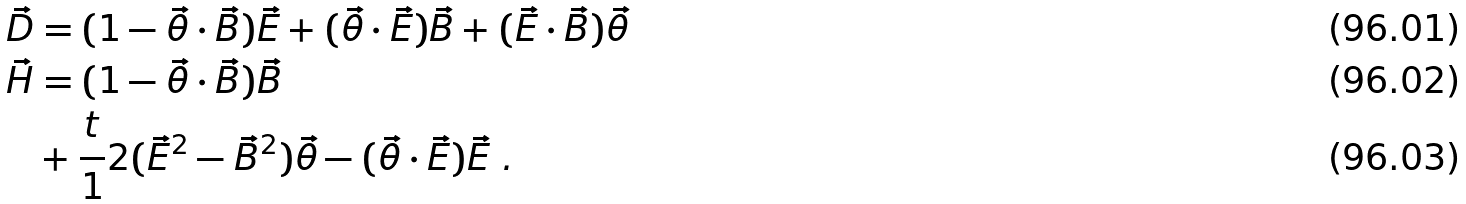Convert formula to latex. <formula><loc_0><loc_0><loc_500><loc_500>\vec { D } & = ( 1 - \vec { \theta } \cdot \vec { B } ) \vec { E } + ( \vec { \theta } \cdot \vec { E } ) \vec { B } + ( \vec { E } \cdot \vec { B } ) \vec { \theta } \\ \vec { H } & = ( 1 - \vec { \theta } \cdot \vec { B } ) \vec { B } \\ & + \frac { t } { 1 } 2 ( \vec { E } ^ { 2 } - \vec { B } ^ { 2 } ) \vec { \theta } - ( \vec { \theta } \cdot \vec { E } ) \vec { E } \ .</formula> 